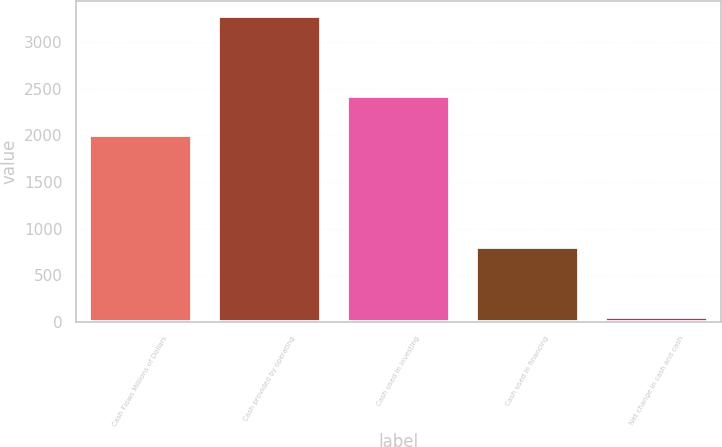Convert chart. <chart><loc_0><loc_0><loc_500><loc_500><bar_chart><fcel>Cash Flows Millions of Dollars<fcel>Cash provided by operating<fcel>Cash used in investing<fcel>Cash used in financing<fcel>Net change in cash and cash<nl><fcel>2007<fcel>3277<fcel>2426<fcel>800<fcel>51<nl></chart> 